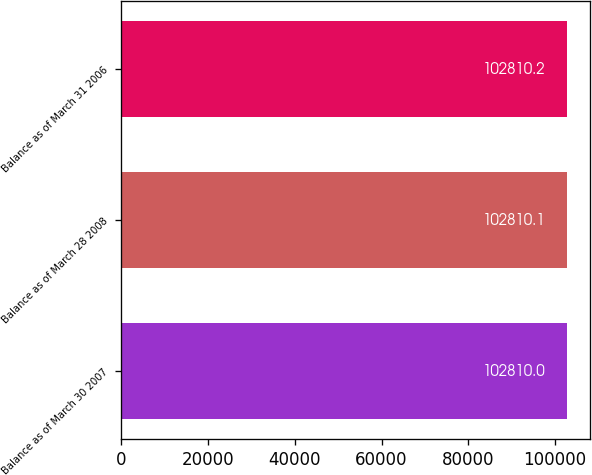<chart> <loc_0><loc_0><loc_500><loc_500><bar_chart><fcel>Balance as of March 30 2007<fcel>Balance as of March 28 2008<fcel>Balance as of March 31 2006<nl><fcel>102810<fcel>102810<fcel>102810<nl></chart> 